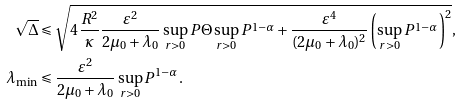Convert formula to latex. <formula><loc_0><loc_0><loc_500><loc_500>\sqrt { \Delta } & \leqslant \sqrt { 4 \frac { R ^ { 2 } } { \kappa } \frac { \varepsilon ^ { 2 } } { 2 \mu _ { 0 } + \lambda _ { 0 } } \sup _ { r > 0 } P \Theta \sup _ { r > 0 } P ^ { 1 - \alpha } + \frac { \varepsilon ^ { 4 } } { ( 2 \mu _ { 0 } + \lambda _ { 0 } ) ^ { 2 } } \left ( \sup _ { r > 0 } P ^ { 1 - \alpha } \right ) ^ { 2 } } , \\ \lambda _ { \min } & \leqslant \frac { \varepsilon ^ { 2 } } { 2 \mu _ { 0 } + \lambda _ { 0 } } \sup _ { r > 0 } P ^ { 1 - \alpha } .</formula> 